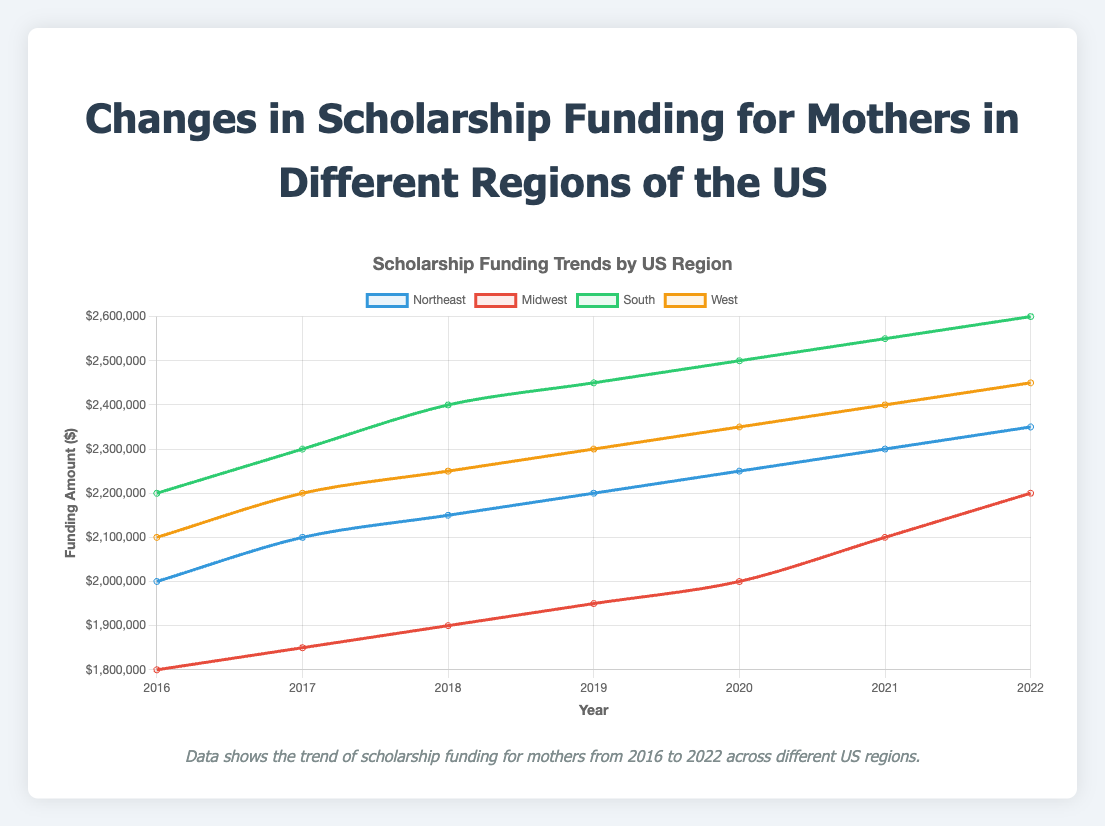Which region showed the highest scholarship funding in 2022? To determine the highest funding in 2022, inspect the line plot's y-values for each region in the year 2022.
Answer: South Which region had the lowest scholarship funding in 2016? To find the region with the lowest funding in 2016, look for the smallest y-value among the regions for the year 2016.
Answer: Midwest By how much did the scholarship funding in the Northeast region increase from 2016 to 2022? Subtract the Northeast's funding in 2016 from its funding in 2022: 2,350,000 - 2,000,000.
Answer: 350,000 Which year saw the largest increase in scholarship funding for the South region? Examine the South region line plot and identify the year where the slope of the line is steepest.
Answer: 2017 Compare the scholarship funding trends for the Midwest and West regions. Which region had a higher increase? Calculate the difference in funding for the Midwest (2,200,000 - 1,800,000) and for the West (2,450,000 - 2,100,000), then compare the two differences.
Answer: Midwest Does any region's funding decrease in any year between 2016 and 2022? Check each line plot for any descending slopes between two consecutive years.
Answer: No What is the average scholarship funding for the Northeast region from 2016 to 2022? Sum the Northeast's funding amounts for each year and divide by the number of years: (2,000,000 + 2,100,000 + 2,150,000 + 2,200,000 + 2,250,000 + 2,300,000 + 2,350,000) / 7.
Answer: 2,192,857 How did the scholarship funding for the South region in 2019 compare to funding in the Midwest region in 2020? Compare the y-values for the South region in 2019 and the Midwest region in 2020.
Answer: South in 2019 is higher What is the total scholarship funding for all regions in 2020? Add the 2020 funding amounts for all regions: 2,250,000 (Northeast) + 2,000,000 (Midwest) + 2,500,000 (South) + 2,350,000 (West).
Answer: 9,100,000 